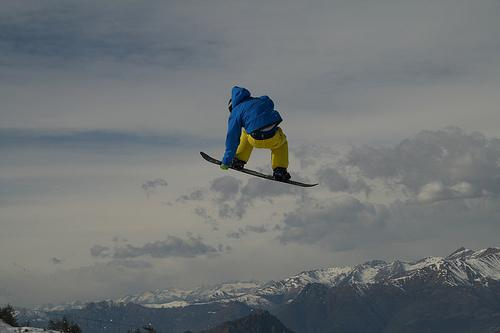Question: where is this picture taken place?
Choices:
A. Park.
B. Ball field.
C. Store.
D. Mountain.
Answer with the letter. Answer: D Question: what is the person doing?
Choices:
A. Walking.
B. Running.
C. Swimming.
D. Snowboarding.
Answer with the letter. Answer: D Question: what color pants is the person wearing?
Choices:
A. Yellow.
B. Blue.
C. Green.
D. Red.
Answer with the letter. Answer: A Question: what is covering the mountains?
Choices:
A. Rocks.
B. Grass.
C. Snow.
D. Sheep.
Answer with the letter. Answer: C Question: when was this picture taken?
Choices:
A. Afternoon.
B. Night time.
C. Sunset.
D. During the day.
Answer with the letter. Answer: D Question: why is the person snowboarding?
Choices:
A. Exercise.
B. Competition.
C. Hobby.
D. Relaxation.
Answer with the letter. Answer: C 